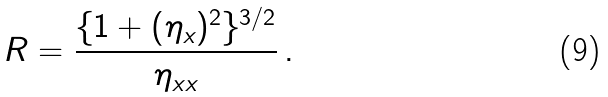Convert formula to latex. <formula><loc_0><loc_0><loc_500><loc_500>R = \frac { \{ 1 + ( \eta _ { x } ) ^ { 2 } \} ^ { 3 / 2 } } { \eta _ { x x } } \, .</formula> 